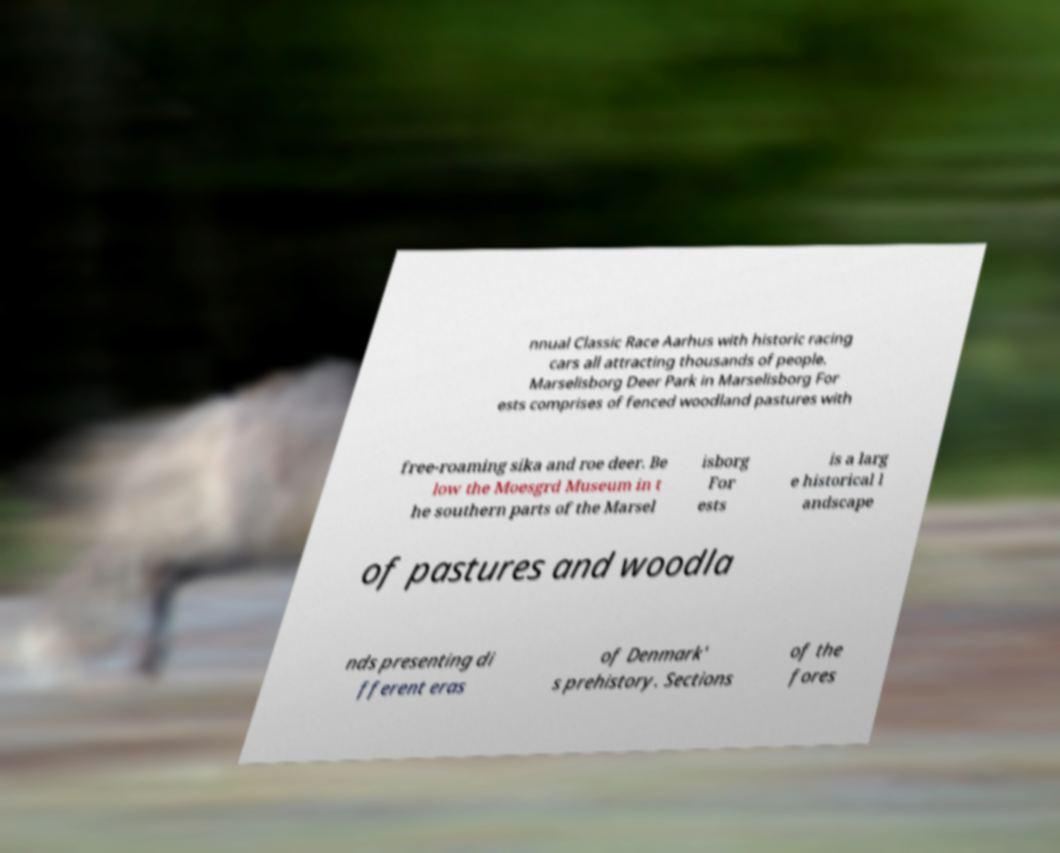I need the written content from this picture converted into text. Can you do that? nnual Classic Race Aarhus with historic racing cars all attracting thousands of people. Marselisborg Deer Park in Marselisborg For ests comprises of fenced woodland pastures with free-roaming sika and roe deer. Be low the Moesgrd Museum in t he southern parts of the Marsel isborg For ests is a larg e historical l andscape of pastures and woodla nds presenting di fferent eras of Denmark' s prehistory. Sections of the fores 